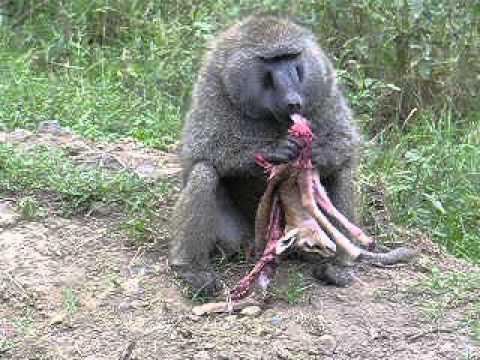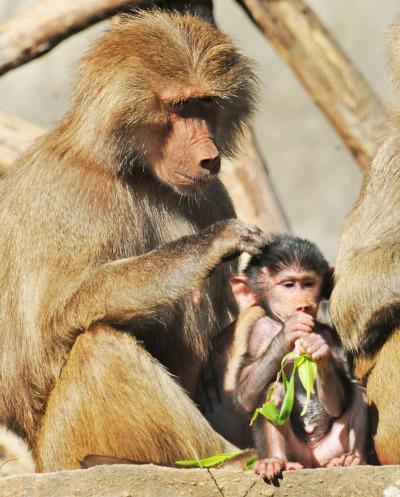The first image is the image on the left, the second image is the image on the right. For the images displayed, is the sentence "A deceased animal is on the grass in front of a primate." factually correct? Answer yes or no. No. The first image is the image on the left, the second image is the image on the right. Examine the images to the left and right. Is the description "An adult baboon is touching a dark-haired young baboon in one image." accurate? Answer yes or no. Yes. 